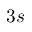<formula> <loc_0><loc_0><loc_500><loc_500>3 s</formula> 